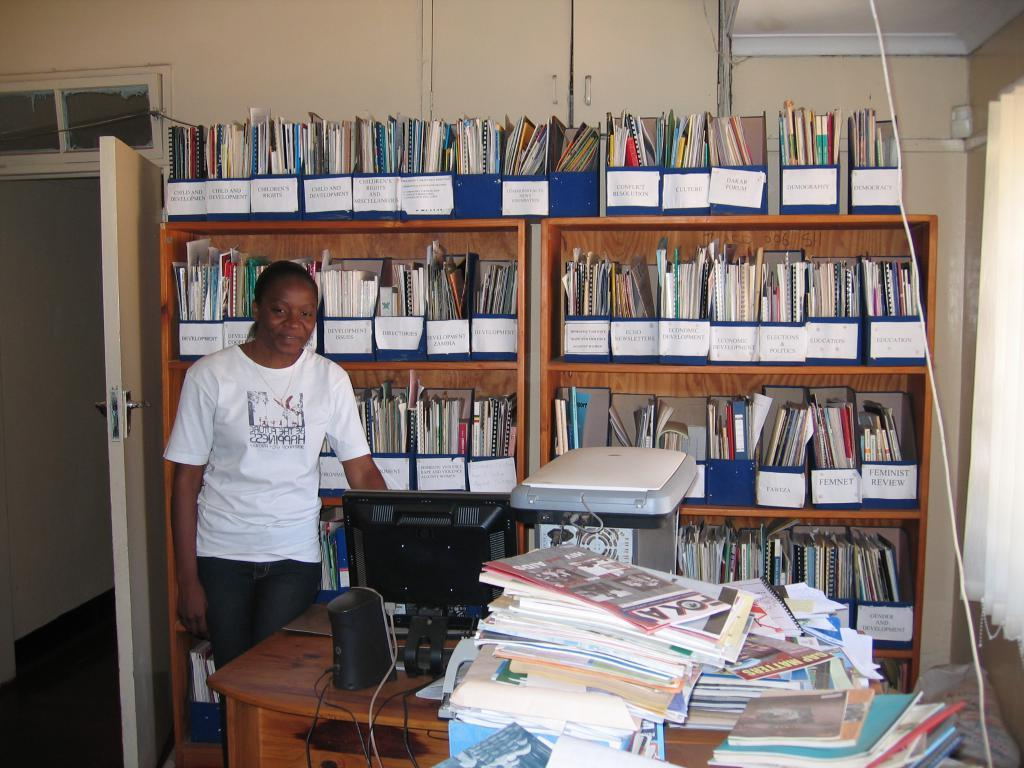Provide a one-sentence caption for the provided image. A shelf full of magazines one marked Economic Development. 